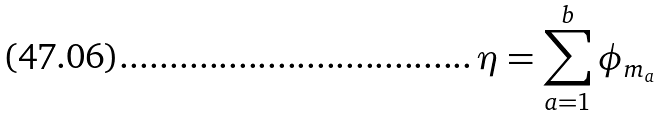<formula> <loc_0><loc_0><loc_500><loc_500>\eta = \sum _ { a = 1 } ^ { b } \phi _ { m _ { a } }</formula> 